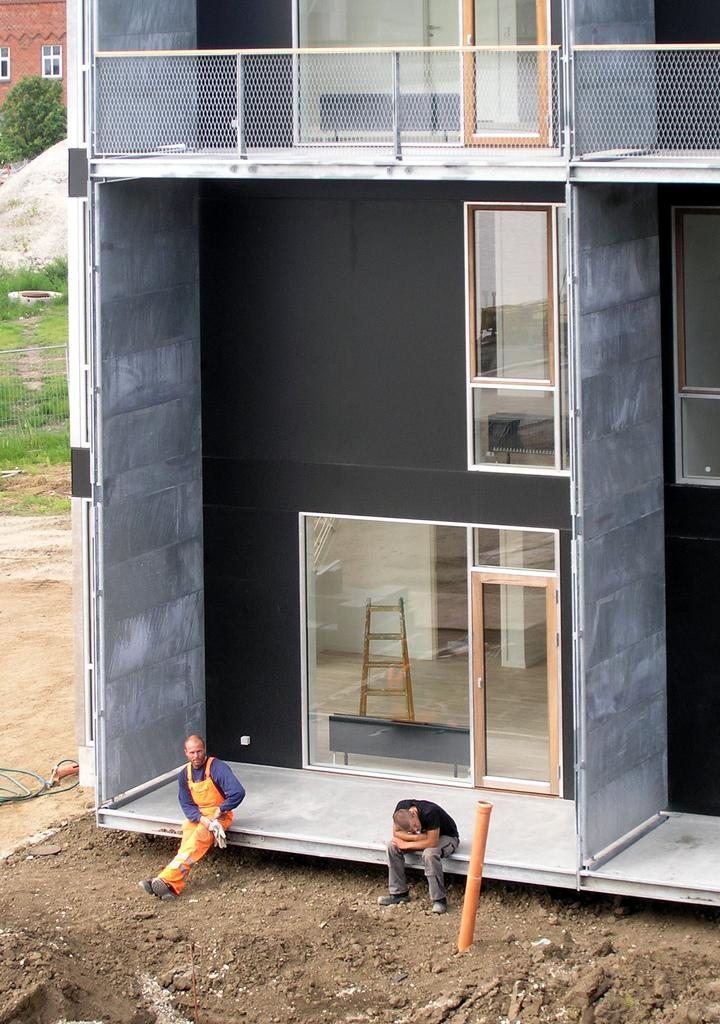What are the people in the image doing? The people in the image are sitting. What type of structure can be seen in the image? There is a building in the image. What material is visible through the glass in the image? A ladder is visible through the glass. What can be seen in the background of the image? There is a wall, windows, a tree, and grass in the background of the image. What type of vegetable is being used as a quarter in the image? There is no vegetable being used as a quarter in the image. What type of fowl can be seen flying in the background of the image? There is no fowl visible in the image; only a tree and grass are present in the background. 